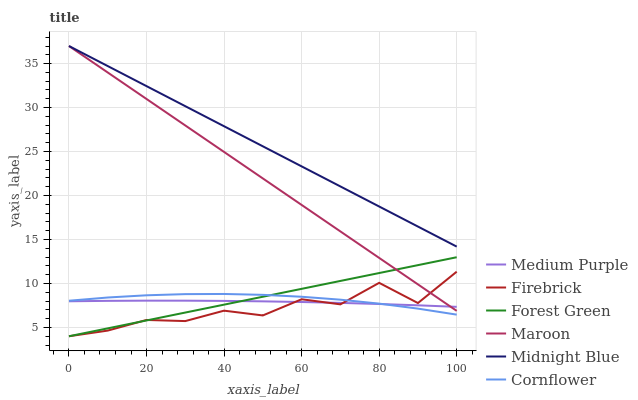Does Midnight Blue have the minimum area under the curve?
Answer yes or no. No. Does Firebrick have the maximum area under the curve?
Answer yes or no. No. Is Midnight Blue the smoothest?
Answer yes or no. No. Is Midnight Blue the roughest?
Answer yes or no. No. Does Midnight Blue have the lowest value?
Answer yes or no. No. Does Firebrick have the highest value?
Answer yes or no. No. Is Medium Purple less than Midnight Blue?
Answer yes or no. Yes. Is Midnight Blue greater than Medium Purple?
Answer yes or no. Yes. Does Medium Purple intersect Midnight Blue?
Answer yes or no. No. 